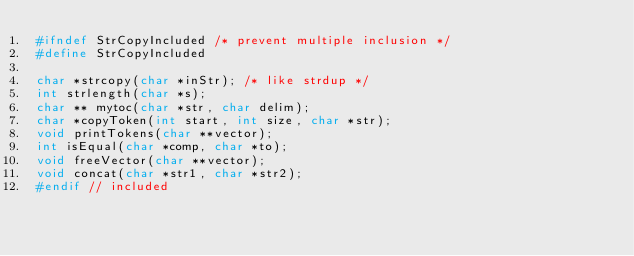<code> <loc_0><loc_0><loc_500><loc_500><_C_>#ifndef StrCopyIncluded /* prevent multiple inclusion */
#define StrCopyIncluded

char *strcopy(char *inStr); /* like strdup */
int strlength(char *s);
char ** mytoc(char *str, char delim);
char *copyToken(int start, int size, char *str);
void printTokens(char **vector);
int isEqual(char *comp, char *to);
void freeVector(char **vector);
void concat(char *str1, char *str2);
#endif // included
</code> 